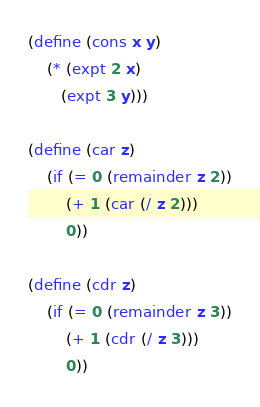Convert code to text. <code><loc_0><loc_0><loc_500><loc_500><_Scheme_>(define (cons x y)
    (* (expt 2 x)
       (expt 3 y)))

(define (car z)
    (if (= 0 (remainder z 2))
        (+ 1 (car (/ z 2)))
        0))

(define (cdr z)
    (if (= 0 (remainder z 3))
        (+ 1 (cdr (/ z 3)))
        0))</code> 